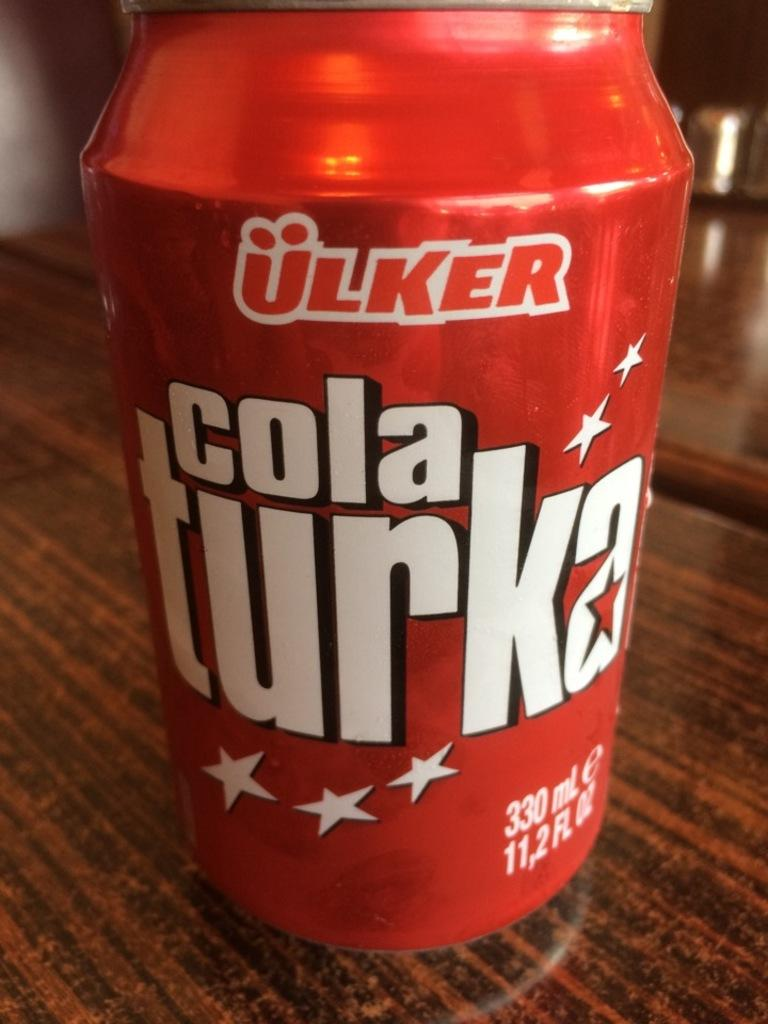Provide a one-sentence caption for the provided image. A red can of Cola Turka is on a wooden surface. 